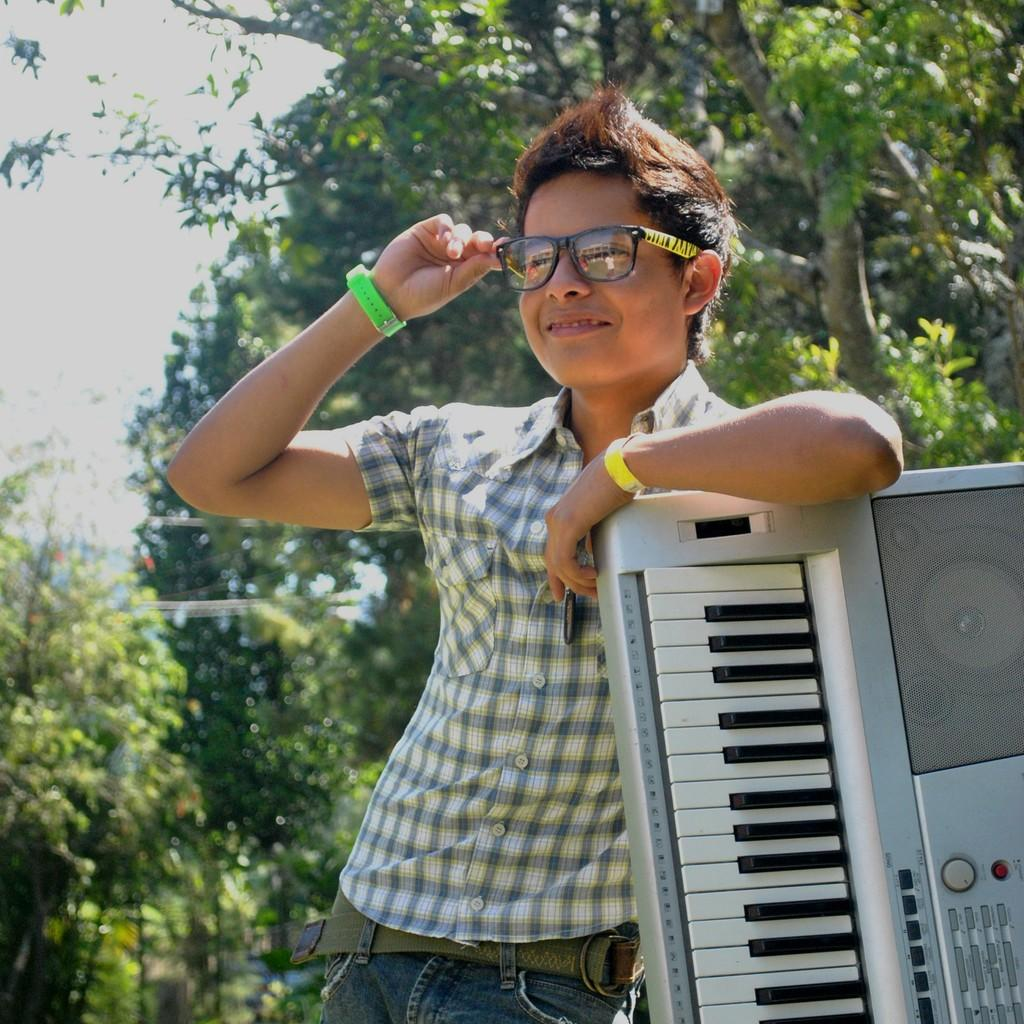What type of scene is depicted in the image? The image is of an outdoor scene. Can you describe the main subject in the image? There is a man in the center of the image. What is the man wearing? The man is wearing a shirt. What is the man's facial expression? The man is smiling. What is the man's posture in the image? The man is standing. What object is on the right side of the image? There is a musical keyboard on the right side of the image. What can be seen in the background of the image? There is a sky and trees visible in the background of the image. How many mice are hiding under the man's shirt in the image? There are no mice present in the image, and therefore none are hiding under the man's shirt. Is the man wearing a veil in the image? No, the man is not wearing a veil in the image; he is wearing a shirt. 